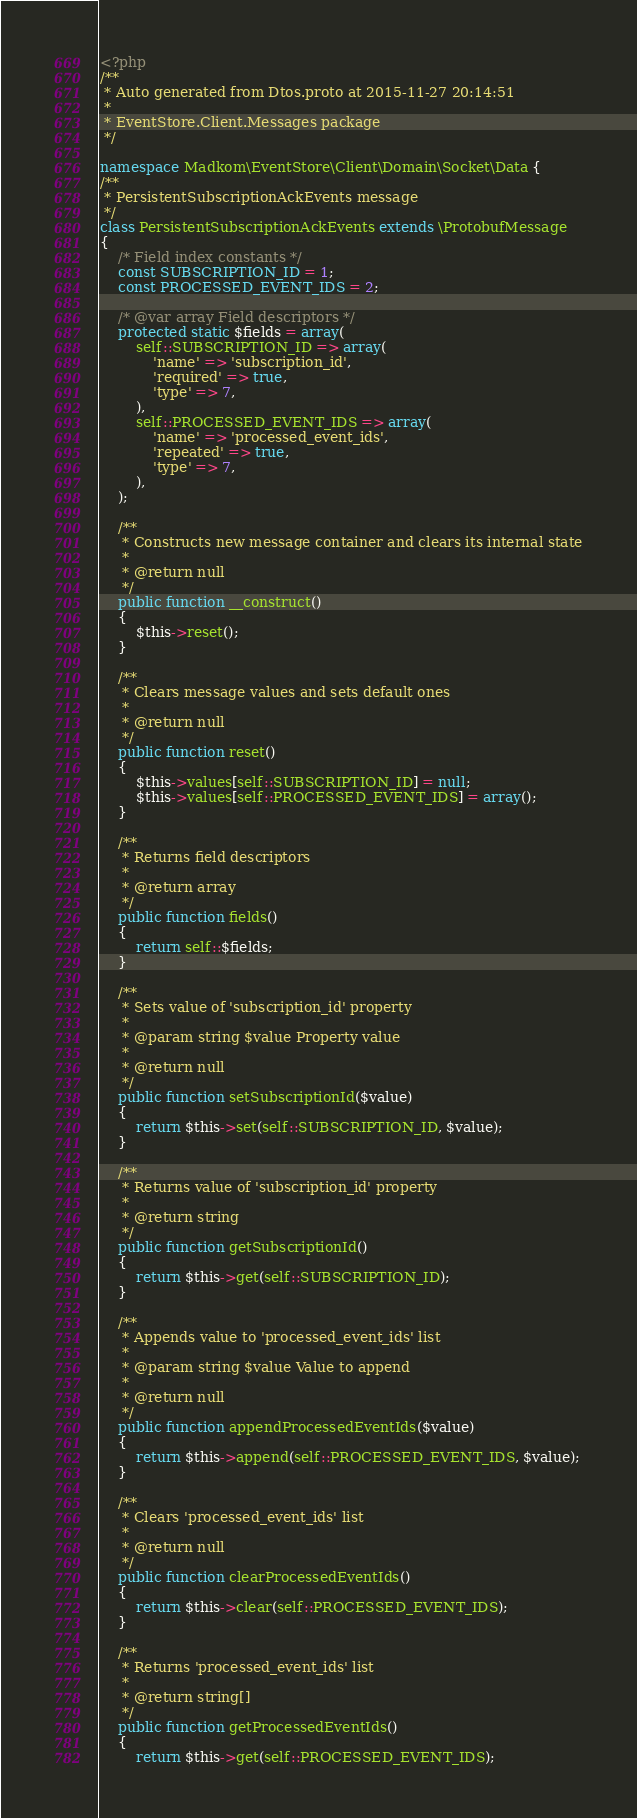<code> <loc_0><loc_0><loc_500><loc_500><_PHP_><?php
/**
 * Auto generated from Dtos.proto at 2015-11-27 20:14:51
 *
 * EventStore.Client.Messages package
 */

namespace Madkom\EventStore\Client\Domain\Socket\Data {
/**
 * PersistentSubscriptionAckEvents message
 */
class PersistentSubscriptionAckEvents extends \ProtobufMessage
{
    /* Field index constants */
    const SUBSCRIPTION_ID = 1;
    const PROCESSED_EVENT_IDS = 2;

    /* @var array Field descriptors */
    protected static $fields = array(
        self::SUBSCRIPTION_ID => array(
            'name' => 'subscription_id',
            'required' => true,
            'type' => 7,
        ),
        self::PROCESSED_EVENT_IDS => array(
            'name' => 'processed_event_ids',
            'repeated' => true,
            'type' => 7,
        ),
    );

    /**
     * Constructs new message container and clears its internal state
     *
     * @return null
     */
    public function __construct()
    {
        $this->reset();
    }

    /**
     * Clears message values and sets default ones
     *
     * @return null
     */
    public function reset()
    {
        $this->values[self::SUBSCRIPTION_ID] = null;
        $this->values[self::PROCESSED_EVENT_IDS] = array();
    }

    /**
     * Returns field descriptors
     *
     * @return array
     */
    public function fields()
    {
        return self::$fields;
    }

    /**
     * Sets value of 'subscription_id' property
     *
     * @param string $value Property value
     *
     * @return null
     */
    public function setSubscriptionId($value)
    {
        return $this->set(self::SUBSCRIPTION_ID, $value);
    }

    /**
     * Returns value of 'subscription_id' property
     *
     * @return string
     */
    public function getSubscriptionId()
    {
        return $this->get(self::SUBSCRIPTION_ID);
    }

    /**
     * Appends value to 'processed_event_ids' list
     *
     * @param string $value Value to append
     *
     * @return null
     */
    public function appendProcessedEventIds($value)
    {
        return $this->append(self::PROCESSED_EVENT_IDS, $value);
    }

    /**
     * Clears 'processed_event_ids' list
     *
     * @return null
     */
    public function clearProcessedEventIds()
    {
        return $this->clear(self::PROCESSED_EVENT_IDS);
    }

    /**
     * Returns 'processed_event_ids' list
     *
     * @return string[]
     */
    public function getProcessedEventIds()
    {
        return $this->get(self::PROCESSED_EVENT_IDS);</code> 